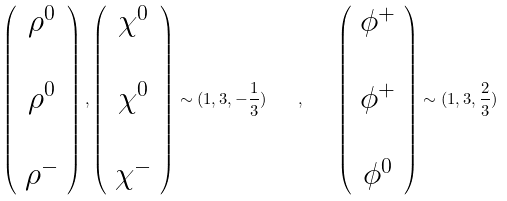Convert formula to latex. <formula><loc_0><loc_0><loc_500><loc_500>\left ( \begin{array} { c } \rho ^ { 0 } \\ \\ \rho ^ { 0 } \\ \\ \rho ^ { - } \end{array} \right ) , \left ( \begin{array} { c } \chi ^ { 0 } \\ \\ \chi ^ { 0 } \\ \\ \chi ^ { - } \end{array} \right ) \sim ( 1 , 3 , - \frac { 1 } { 3 } ) \quad , \quad \left ( \begin{array} { c } \phi ^ { + } \\ \\ \phi ^ { + } \\ \\ \phi ^ { 0 } \end{array} \right ) \sim ( 1 , 3 , \frac { 2 } { 3 } )</formula> 